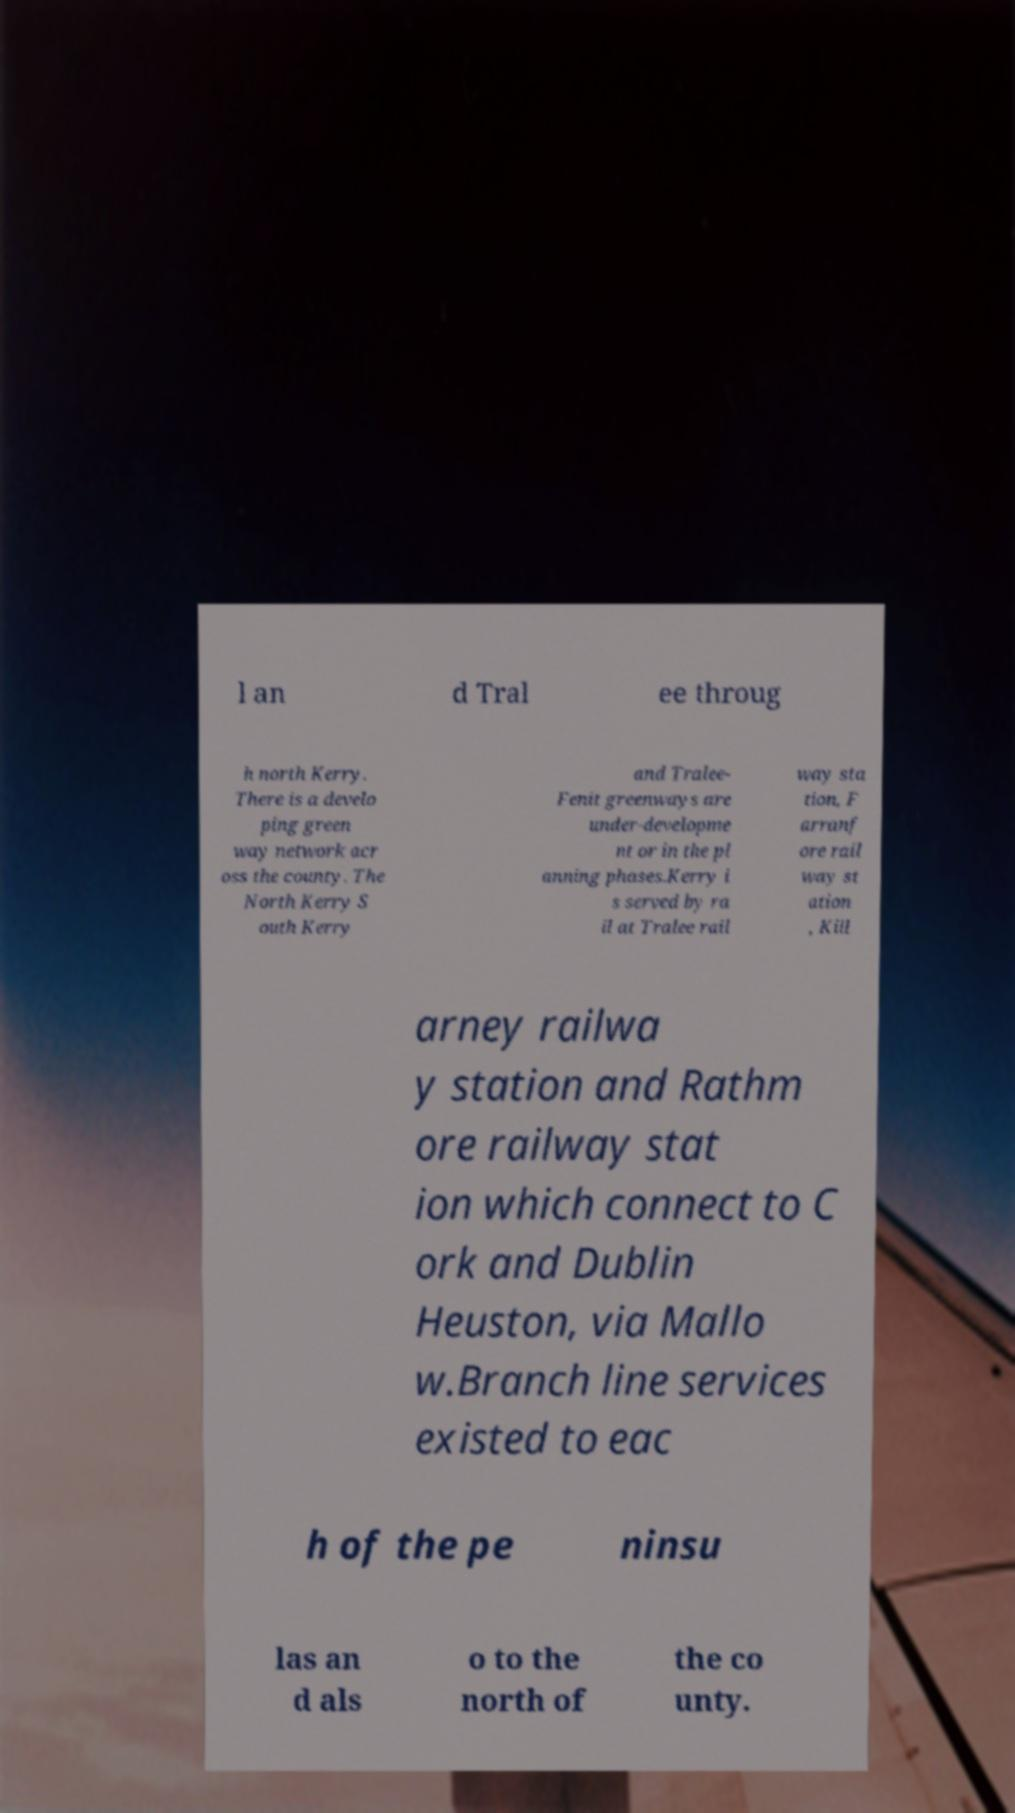Could you assist in decoding the text presented in this image and type it out clearly? l an d Tral ee throug h north Kerry. There is a develo ping green way network acr oss the county. The North Kerry S outh Kerry and Tralee- Fenit greenways are under-developme nt or in the pl anning phases.Kerry i s served by ra il at Tralee rail way sta tion, F arranf ore rail way st ation , Kill arney railwa y station and Rathm ore railway stat ion which connect to C ork and Dublin Heuston, via Mallo w.Branch line services existed to eac h of the pe ninsu las an d als o to the north of the co unty. 